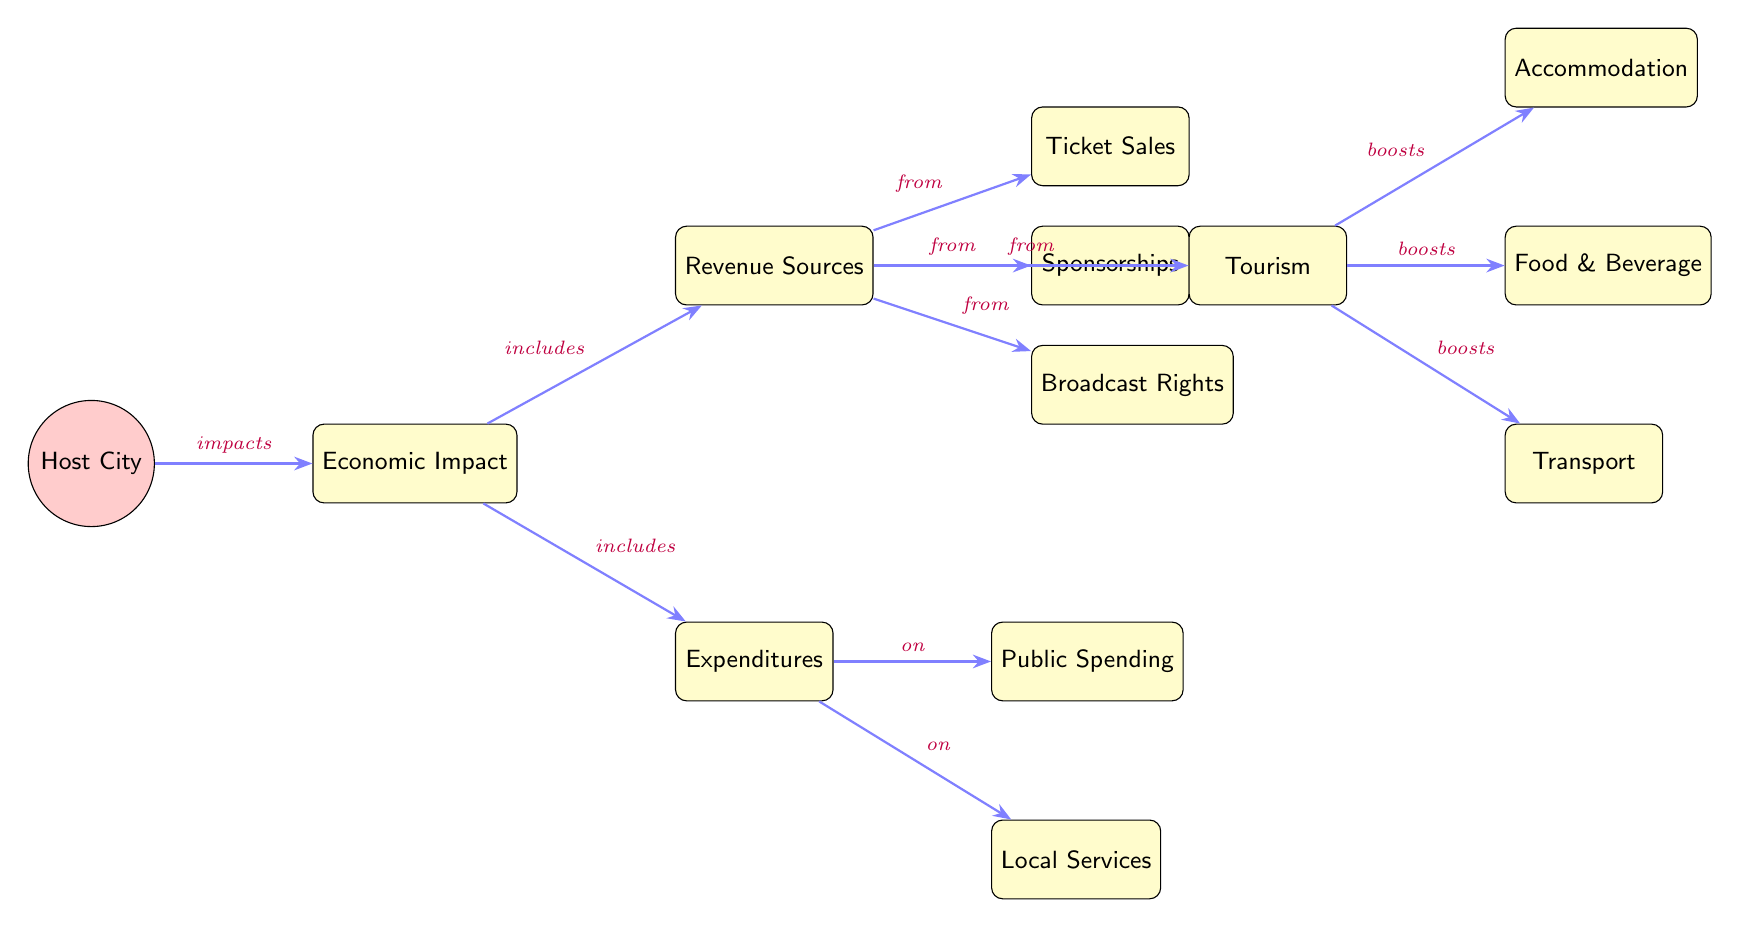What is the main subject of the diagram? The main subject of the diagram is the "Host City," which is shown as the starting point in the flow of information through the diagram.
Answer: Host City How many revenue sources are listed? There are four revenue sources identified in the diagram: Ticket Sales, Sponsorships, Broadcast Rights, and Tourism. By counting the individual boxes connected to the Revenue Sources node, we reach the total.
Answer: 4 What type of impacts are shown in relation to the host city? The diagram shows the impact of the host city on the "Economic Impact." This relationship is depicted through the edge labeled "impacts," connecting the Host City directly to the Economic Impact node.
Answer: impacts Which revenue source boosts local accommodation? The tourism node boosts local accommodations as indicated by the edge labeled "boosts," leading from Tourism to the Accommodation node.
Answer: Tourism What are the two categories of expenditures mentioned? The two categories of expenditures are Local Services and Public Spending. By inspecting the Expenditures node, we can see these two branches directly stemming from it.
Answer: Local Services, Public Spending Which revenue source is related to audience engagement through media? The Broadcast Rights revenue source relates to audience engagement through media, as it represents the financial income from entities that broadcast the boxing event.
Answer: Broadcast Rights How does tourism contribute to the economy according to the diagram? Tourism contributes to the economy through several aspects: it boosts Accommodation, Food & Beverage, and Transport. This is shown by the edges from the Tourism node to each of these three elements.
Answer: Accommodation, Food & Beverage, Transport What type of expenditure relates directly to community services? The expenditure related to community services is Local Services, as indicated by the node directly connected to Expenditures and marked with "on."
Answer: Local Services What type of relationship exists between the Economic Impact and Revenue Sources? The relationship is one of inclusion, shown by the edge labeled "includes," indicating that the Economic Impact encompasses various Revenue Sources.
Answer: includes 